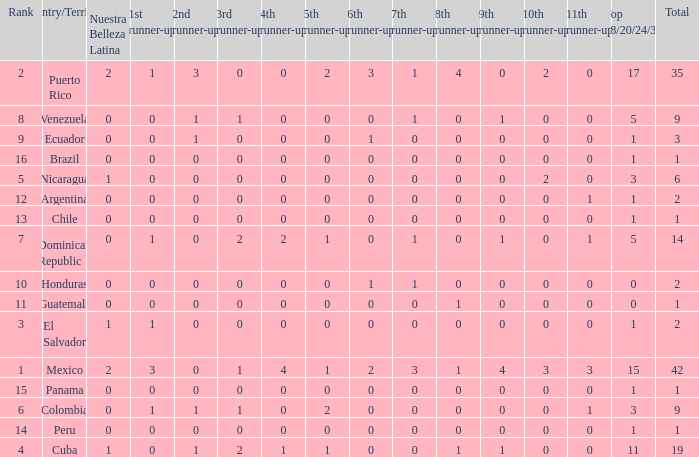What is the total number of 3rd runners-up of the country ranked lower than 12 with a 10th runner-up of 0, an 8th runner-up less than 1, and a 7th runner-up of 0? 4.0. 